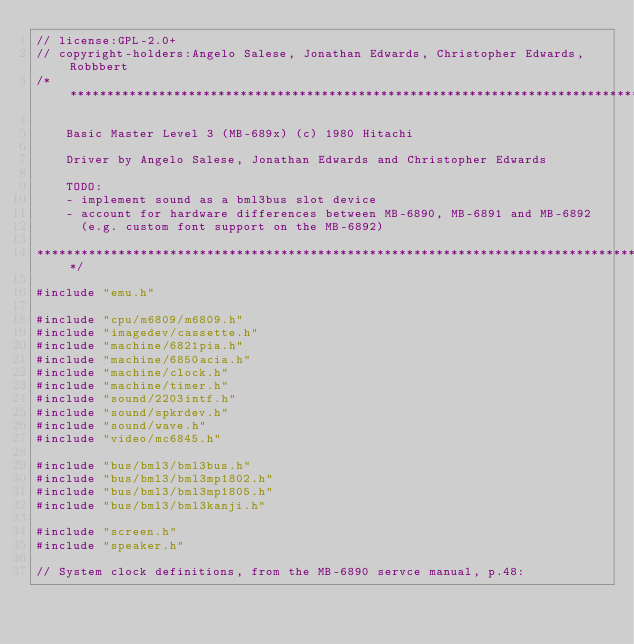<code> <loc_0><loc_0><loc_500><loc_500><_C++_>// license:GPL-2.0+
// copyright-holders:Angelo Salese, Jonathan Edwards, Christopher Edwards,Robbbert
/**************************************************************************************

    Basic Master Level 3 (MB-689x) (c) 1980 Hitachi

    Driver by Angelo Salese, Jonathan Edwards and Christopher Edwards

    TODO:
    - implement sound as a bml3bus slot device
    - account for hardware differences between MB-6890, MB-6891 and MB-6892
      (e.g. custom font support on the MB-6892)

**************************************************************************************/

#include "emu.h"

#include "cpu/m6809/m6809.h"
#include "imagedev/cassette.h"
#include "machine/6821pia.h"
#include "machine/6850acia.h"
#include "machine/clock.h"
#include "machine/timer.h"
#include "sound/2203intf.h"
#include "sound/spkrdev.h"
#include "sound/wave.h"
#include "video/mc6845.h"

#include "bus/bml3/bml3bus.h"
#include "bus/bml3/bml3mp1802.h"
#include "bus/bml3/bml3mp1805.h"
#include "bus/bml3/bml3kanji.h"

#include "screen.h"
#include "speaker.h"

// System clock definitions, from the MB-6890 servce manual, p.48:
</code> 